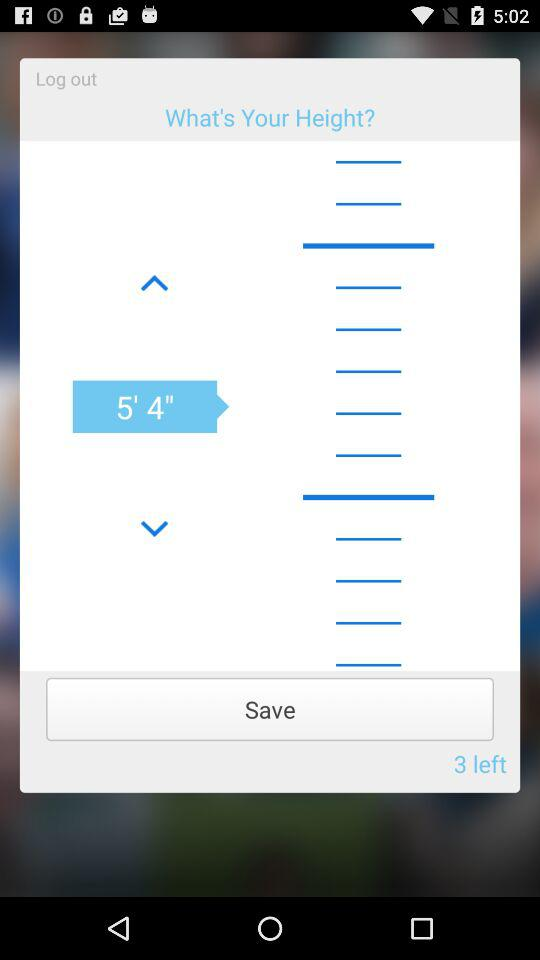What's the number of inputs left? The number of inputs left is 3. 